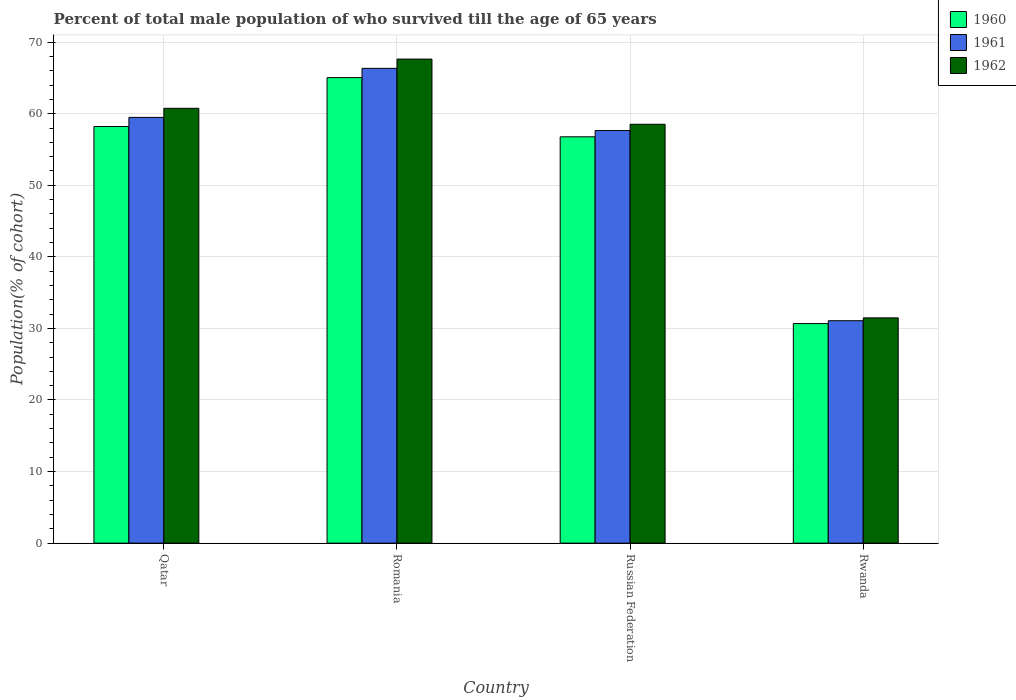How many different coloured bars are there?
Provide a short and direct response. 3. How many groups of bars are there?
Your answer should be compact. 4. How many bars are there on the 4th tick from the left?
Your answer should be compact. 3. How many bars are there on the 4th tick from the right?
Offer a very short reply. 3. What is the label of the 3rd group of bars from the left?
Offer a very short reply. Russian Federation. What is the percentage of total male population who survived till the age of 65 years in 1960 in Rwanda?
Keep it short and to the point. 30.68. Across all countries, what is the maximum percentage of total male population who survived till the age of 65 years in 1962?
Provide a succinct answer. 67.63. Across all countries, what is the minimum percentage of total male population who survived till the age of 65 years in 1961?
Give a very brief answer. 31.07. In which country was the percentage of total male population who survived till the age of 65 years in 1962 maximum?
Provide a succinct answer. Romania. In which country was the percentage of total male population who survived till the age of 65 years in 1962 minimum?
Make the answer very short. Rwanda. What is the total percentage of total male population who survived till the age of 65 years in 1960 in the graph?
Offer a very short reply. 210.7. What is the difference between the percentage of total male population who survived till the age of 65 years in 1960 in Russian Federation and that in Rwanda?
Keep it short and to the point. 26.09. What is the difference between the percentage of total male population who survived till the age of 65 years in 1960 in Qatar and the percentage of total male population who survived till the age of 65 years in 1961 in Romania?
Keep it short and to the point. -8.12. What is the average percentage of total male population who survived till the age of 65 years in 1962 per country?
Ensure brevity in your answer.  54.59. What is the difference between the percentage of total male population who survived till the age of 65 years of/in 1960 and percentage of total male population who survived till the age of 65 years of/in 1962 in Russian Federation?
Make the answer very short. -1.75. What is the ratio of the percentage of total male population who survived till the age of 65 years in 1960 in Qatar to that in Romania?
Your answer should be compact. 0.9. Is the percentage of total male population who survived till the age of 65 years in 1961 in Qatar less than that in Rwanda?
Provide a short and direct response. No. Is the difference between the percentage of total male population who survived till the age of 65 years in 1960 in Russian Federation and Rwanda greater than the difference between the percentage of total male population who survived till the age of 65 years in 1962 in Russian Federation and Rwanda?
Your response must be concise. No. What is the difference between the highest and the second highest percentage of total male population who survived till the age of 65 years in 1961?
Offer a very short reply. -8.69. What is the difference between the highest and the lowest percentage of total male population who survived till the age of 65 years in 1960?
Provide a short and direct response. 34.36. Is the sum of the percentage of total male population who survived till the age of 65 years in 1961 in Qatar and Romania greater than the maximum percentage of total male population who survived till the age of 65 years in 1962 across all countries?
Offer a terse response. Yes. What does the 3rd bar from the left in Russian Federation represents?
Your response must be concise. 1962. What does the 3rd bar from the right in Russian Federation represents?
Offer a terse response. 1960. Is it the case that in every country, the sum of the percentage of total male population who survived till the age of 65 years in 1962 and percentage of total male population who survived till the age of 65 years in 1960 is greater than the percentage of total male population who survived till the age of 65 years in 1961?
Keep it short and to the point. Yes. Are the values on the major ticks of Y-axis written in scientific E-notation?
Provide a succinct answer. No. Does the graph contain grids?
Provide a short and direct response. Yes. How many legend labels are there?
Keep it short and to the point. 3. How are the legend labels stacked?
Your response must be concise. Vertical. What is the title of the graph?
Provide a succinct answer. Percent of total male population of who survived till the age of 65 years. Does "1976" appear as one of the legend labels in the graph?
Provide a succinct answer. No. What is the label or title of the Y-axis?
Your answer should be very brief. Population(% of cohort). What is the Population(% of cohort) in 1960 in Qatar?
Your response must be concise. 58.21. What is the Population(% of cohort) in 1961 in Qatar?
Your answer should be very brief. 59.48. What is the Population(% of cohort) in 1962 in Qatar?
Your response must be concise. 60.75. What is the Population(% of cohort) of 1960 in Romania?
Offer a very short reply. 65.04. What is the Population(% of cohort) in 1961 in Romania?
Keep it short and to the point. 66.33. What is the Population(% of cohort) in 1962 in Romania?
Make the answer very short. 67.63. What is the Population(% of cohort) in 1960 in Russian Federation?
Offer a very short reply. 56.77. What is the Population(% of cohort) in 1961 in Russian Federation?
Provide a succinct answer. 57.65. What is the Population(% of cohort) of 1962 in Russian Federation?
Make the answer very short. 58.52. What is the Population(% of cohort) of 1960 in Rwanda?
Make the answer very short. 30.68. What is the Population(% of cohort) of 1961 in Rwanda?
Your answer should be compact. 31.07. What is the Population(% of cohort) in 1962 in Rwanda?
Keep it short and to the point. 31.47. Across all countries, what is the maximum Population(% of cohort) in 1960?
Keep it short and to the point. 65.04. Across all countries, what is the maximum Population(% of cohort) in 1961?
Give a very brief answer. 66.33. Across all countries, what is the maximum Population(% of cohort) of 1962?
Offer a very short reply. 67.63. Across all countries, what is the minimum Population(% of cohort) of 1960?
Offer a very short reply. 30.68. Across all countries, what is the minimum Population(% of cohort) in 1961?
Ensure brevity in your answer.  31.07. Across all countries, what is the minimum Population(% of cohort) of 1962?
Keep it short and to the point. 31.47. What is the total Population(% of cohort) of 1960 in the graph?
Provide a short and direct response. 210.7. What is the total Population(% of cohort) in 1961 in the graph?
Provide a short and direct response. 214.54. What is the total Population(% of cohort) in 1962 in the graph?
Offer a very short reply. 218.37. What is the difference between the Population(% of cohort) in 1960 in Qatar and that in Romania?
Make the answer very short. -6.82. What is the difference between the Population(% of cohort) in 1961 in Qatar and that in Romania?
Make the answer very short. -6.85. What is the difference between the Population(% of cohort) of 1962 in Qatar and that in Romania?
Keep it short and to the point. -6.88. What is the difference between the Population(% of cohort) of 1960 in Qatar and that in Russian Federation?
Give a very brief answer. 1.44. What is the difference between the Population(% of cohort) of 1961 in Qatar and that in Russian Federation?
Offer a terse response. 1.84. What is the difference between the Population(% of cohort) in 1962 in Qatar and that in Russian Federation?
Offer a terse response. 2.23. What is the difference between the Population(% of cohort) of 1960 in Qatar and that in Rwanda?
Make the answer very short. 27.54. What is the difference between the Population(% of cohort) in 1961 in Qatar and that in Rwanda?
Offer a terse response. 28.41. What is the difference between the Population(% of cohort) in 1962 in Qatar and that in Rwanda?
Make the answer very short. 29.28. What is the difference between the Population(% of cohort) in 1960 in Romania and that in Russian Federation?
Ensure brevity in your answer.  8.27. What is the difference between the Population(% of cohort) of 1961 in Romania and that in Russian Federation?
Provide a short and direct response. 8.69. What is the difference between the Population(% of cohort) of 1962 in Romania and that in Russian Federation?
Make the answer very short. 9.11. What is the difference between the Population(% of cohort) of 1960 in Romania and that in Rwanda?
Your answer should be very brief. 34.36. What is the difference between the Population(% of cohort) of 1961 in Romania and that in Rwanda?
Ensure brevity in your answer.  35.26. What is the difference between the Population(% of cohort) in 1962 in Romania and that in Rwanda?
Give a very brief answer. 36.16. What is the difference between the Population(% of cohort) in 1960 in Russian Federation and that in Rwanda?
Provide a short and direct response. 26.09. What is the difference between the Population(% of cohort) of 1961 in Russian Federation and that in Rwanda?
Make the answer very short. 26.57. What is the difference between the Population(% of cohort) of 1962 in Russian Federation and that in Rwanda?
Make the answer very short. 27.05. What is the difference between the Population(% of cohort) in 1960 in Qatar and the Population(% of cohort) in 1961 in Romania?
Keep it short and to the point. -8.12. What is the difference between the Population(% of cohort) in 1960 in Qatar and the Population(% of cohort) in 1962 in Romania?
Offer a terse response. -9.42. What is the difference between the Population(% of cohort) of 1961 in Qatar and the Population(% of cohort) of 1962 in Romania?
Ensure brevity in your answer.  -8.15. What is the difference between the Population(% of cohort) in 1960 in Qatar and the Population(% of cohort) in 1961 in Russian Federation?
Your answer should be very brief. 0.57. What is the difference between the Population(% of cohort) in 1960 in Qatar and the Population(% of cohort) in 1962 in Russian Federation?
Ensure brevity in your answer.  -0.31. What is the difference between the Population(% of cohort) in 1961 in Qatar and the Population(% of cohort) in 1962 in Russian Federation?
Give a very brief answer. 0.96. What is the difference between the Population(% of cohort) of 1960 in Qatar and the Population(% of cohort) of 1961 in Rwanda?
Your answer should be compact. 27.14. What is the difference between the Population(% of cohort) of 1960 in Qatar and the Population(% of cohort) of 1962 in Rwanda?
Keep it short and to the point. 26.74. What is the difference between the Population(% of cohort) in 1961 in Qatar and the Population(% of cohort) in 1962 in Rwanda?
Your answer should be compact. 28.01. What is the difference between the Population(% of cohort) of 1960 in Romania and the Population(% of cohort) of 1961 in Russian Federation?
Offer a terse response. 7.39. What is the difference between the Population(% of cohort) in 1960 in Romania and the Population(% of cohort) in 1962 in Russian Federation?
Your answer should be compact. 6.52. What is the difference between the Population(% of cohort) of 1961 in Romania and the Population(% of cohort) of 1962 in Russian Federation?
Your response must be concise. 7.81. What is the difference between the Population(% of cohort) of 1960 in Romania and the Population(% of cohort) of 1961 in Rwanda?
Your response must be concise. 33.96. What is the difference between the Population(% of cohort) of 1960 in Romania and the Population(% of cohort) of 1962 in Rwanda?
Give a very brief answer. 33.57. What is the difference between the Population(% of cohort) in 1961 in Romania and the Population(% of cohort) in 1962 in Rwanda?
Offer a very short reply. 34.86. What is the difference between the Population(% of cohort) of 1960 in Russian Federation and the Population(% of cohort) of 1961 in Rwanda?
Make the answer very short. 25.69. What is the difference between the Population(% of cohort) in 1960 in Russian Federation and the Population(% of cohort) in 1962 in Rwanda?
Keep it short and to the point. 25.3. What is the difference between the Population(% of cohort) in 1961 in Russian Federation and the Population(% of cohort) in 1962 in Rwanda?
Provide a succinct answer. 26.17. What is the average Population(% of cohort) in 1960 per country?
Provide a succinct answer. 52.67. What is the average Population(% of cohort) of 1961 per country?
Provide a short and direct response. 53.63. What is the average Population(% of cohort) of 1962 per country?
Your response must be concise. 54.59. What is the difference between the Population(% of cohort) of 1960 and Population(% of cohort) of 1961 in Qatar?
Offer a terse response. -1.27. What is the difference between the Population(% of cohort) of 1960 and Population(% of cohort) of 1962 in Qatar?
Keep it short and to the point. -2.54. What is the difference between the Population(% of cohort) in 1961 and Population(% of cohort) in 1962 in Qatar?
Provide a short and direct response. -1.27. What is the difference between the Population(% of cohort) of 1960 and Population(% of cohort) of 1961 in Romania?
Your response must be concise. -1.3. What is the difference between the Population(% of cohort) in 1960 and Population(% of cohort) in 1962 in Romania?
Offer a terse response. -2.59. What is the difference between the Population(% of cohort) of 1961 and Population(% of cohort) of 1962 in Romania?
Offer a terse response. -1.3. What is the difference between the Population(% of cohort) of 1960 and Population(% of cohort) of 1961 in Russian Federation?
Offer a terse response. -0.88. What is the difference between the Population(% of cohort) of 1960 and Population(% of cohort) of 1962 in Russian Federation?
Your answer should be very brief. -1.75. What is the difference between the Population(% of cohort) in 1961 and Population(% of cohort) in 1962 in Russian Federation?
Offer a terse response. -0.88. What is the difference between the Population(% of cohort) in 1960 and Population(% of cohort) in 1961 in Rwanda?
Keep it short and to the point. -0.4. What is the difference between the Population(% of cohort) in 1960 and Population(% of cohort) in 1962 in Rwanda?
Your answer should be very brief. -0.79. What is the difference between the Population(% of cohort) in 1961 and Population(% of cohort) in 1962 in Rwanda?
Your answer should be compact. -0.4. What is the ratio of the Population(% of cohort) in 1960 in Qatar to that in Romania?
Keep it short and to the point. 0.9. What is the ratio of the Population(% of cohort) in 1961 in Qatar to that in Romania?
Give a very brief answer. 0.9. What is the ratio of the Population(% of cohort) of 1962 in Qatar to that in Romania?
Your answer should be compact. 0.9. What is the ratio of the Population(% of cohort) in 1960 in Qatar to that in Russian Federation?
Your answer should be very brief. 1.03. What is the ratio of the Population(% of cohort) in 1961 in Qatar to that in Russian Federation?
Provide a short and direct response. 1.03. What is the ratio of the Population(% of cohort) in 1962 in Qatar to that in Russian Federation?
Your answer should be compact. 1.04. What is the ratio of the Population(% of cohort) in 1960 in Qatar to that in Rwanda?
Ensure brevity in your answer.  1.9. What is the ratio of the Population(% of cohort) in 1961 in Qatar to that in Rwanda?
Give a very brief answer. 1.91. What is the ratio of the Population(% of cohort) in 1962 in Qatar to that in Rwanda?
Keep it short and to the point. 1.93. What is the ratio of the Population(% of cohort) of 1960 in Romania to that in Russian Federation?
Make the answer very short. 1.15. What is the ratio of the Population(% of cohort) in 1961 in Romania to that in Russian Federation?
Provide a short and direct response. 1.15. What is the ratio of the Population(% of cohort) in 1962 in Romania to that in Russian Federation?
Provide a succinct answer. 1.16. What is the ratio of the Population(% of cohort) of 1960 in Romania to that in Rwanda?
Keep it short and to the point. 2.12. What is the ratio of the Population(% of cohort) in 1961 in Romania to that in Rwanda?
Give a very brief answer. 2.13. What is the ratio of the Population(% of cohort) in 1962 in Romania to that in Rwanda?
Ensure brevity in your answer.  2.15. What is the ratio of the Population(% of cohort) of 1960 in Russian Federation to that in Rwanda?
Your answer should be compact. 1.85. What is the ratio of the Population(% of cohort) of 1961 in Russian Federation to that in Rwanda?
Ensure brevity in your answer.  1.85. What is the ratio of the Population(% of cohort) of 1962 in Russian Federation to that in Rwanda?
Provide a succinct answer. 1.86. What is the difference between the highest and the second highest Population(% of cohort) of 1960?
Your answer should be compact. 6.82. What is the difference between the highest and the second highest Population(% of cohort) of 1961?
Make the answer very short. 6.85. What is the difference between the highest and the second highest Population(% of cohort) of 1962?
Your answer should be compact. 6.88. What is the difference between the highest and the lowest Population(% of cohort) in 1960?
Provide a short and direct response. 34.36. What is the difference between the highest and the lowest Population(% of cohort) in 1961?
Your answer should be compact. 35.26. What is the difference between the highest and the lowest Population(% of cohort) in 1962?
Provide a succinct answer. 36.16. 